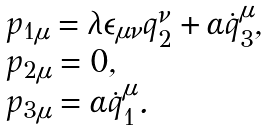Convert formula to latex. <formula><loc_0><loc_0><loc_500><loc_500>\begin{array} { l } p _ { 1 \mu } = \lambda \epsilon _ { \mu \nu } q _ { 2 } ^ { \nu } + \alpha \dot { q } _ { 3 } ^ { \mu } , \\ p _ { 2 \mu } = 0 , \\ p _ { 3 \mu } = \alpha \dot { q } _ { 1 } ^ { \mu } . \end{array}</formula> 